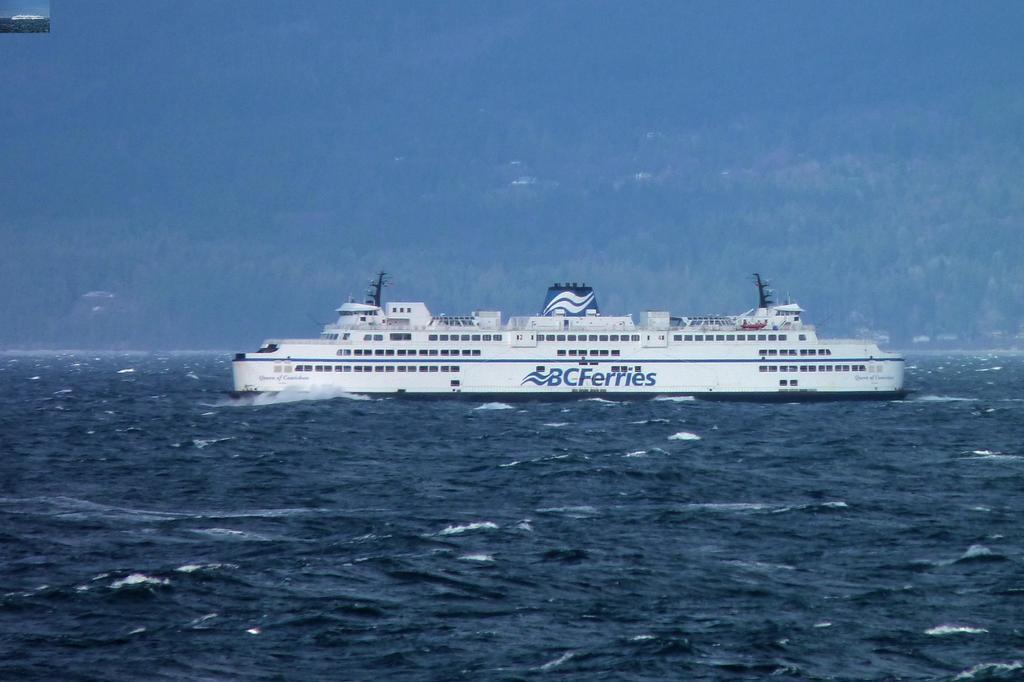Please provide a concise description of this image. At the bottom, we see water and this water might be in the sea. In the middle, we see the ship sailing on the water. This ship is in white color. In the background, we see the sky, which is blue in color. 